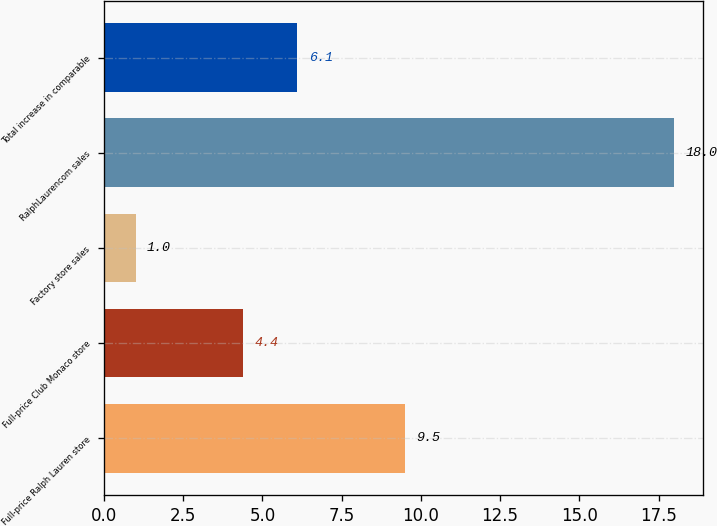Convert chart. <chart><loc_0><loc_0><loc_500><loc_500><bar_chart><fcel>Full-price Ralph Lauren store<fcel>Full-price Club Monaco store<fcel>Factory store sales<fcel>RalphLaurencom sales<fcel>Total increase in comparable<nl><fcel>9.5<fcel>4.4<fcel>1<fcel>18<fcel>6.1<nl></chart> 